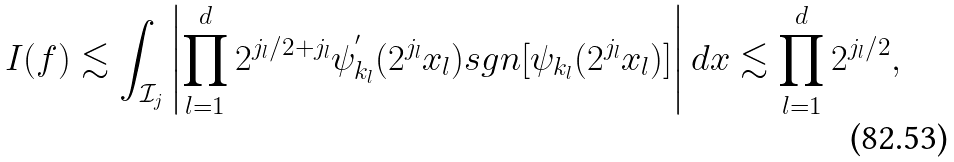<formula> <loc_0><loc_0><loc_500><loc_500>I ( f ) \lesssim \int _ { \mathcal { I } _ { j } } \left | \prod _ { l = 1 } ^ { d } 2 ^ { j _ { l } / 2 + j _ { l } } \psi ^ { ^ { \prime } } _ { k _ { l } } ( 2 ^ { j _ { l } } x _ { l } ) s g n [ \psi _ { k _ { l } } ( 2 ^ { j _ { l } } x _ { l } ) ] \right | d x \lesssim \prod _ { l = 1 } ^ { d } 2 ^ { j _ { l } / 2 } ,</formula> 